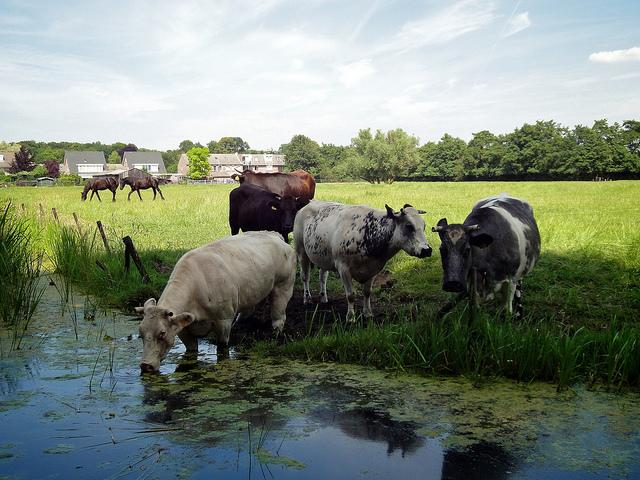Why does the animal have its head to the water? drinking 